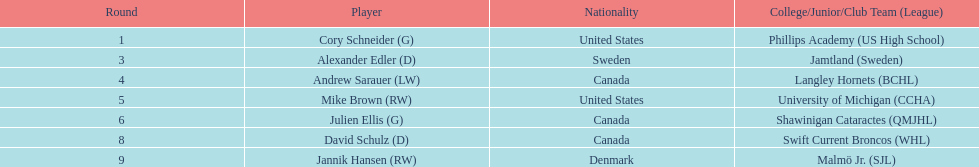Who is the only player to have denmark listed as their nationality? Jannik Hansen (RW). 